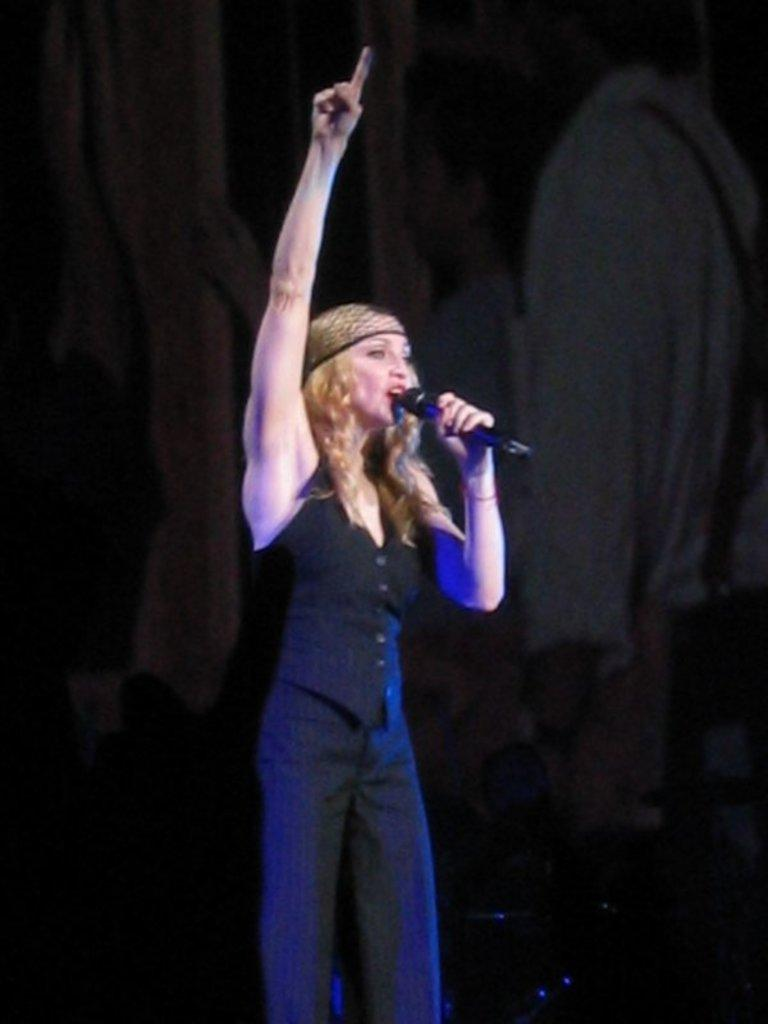Who is the main subject in the image? There is a woman in the image. What is the woman wearing? The woman is wearing a black dress. What is the woman holding in her hand? The woman is holding a mic in her hand. What can be observed about the background of the image? The background of the image is dark. What fact about the prose can be observed in the image? There is no prose present in the image, as it features a woman holding a mic and wearing a black dress. 